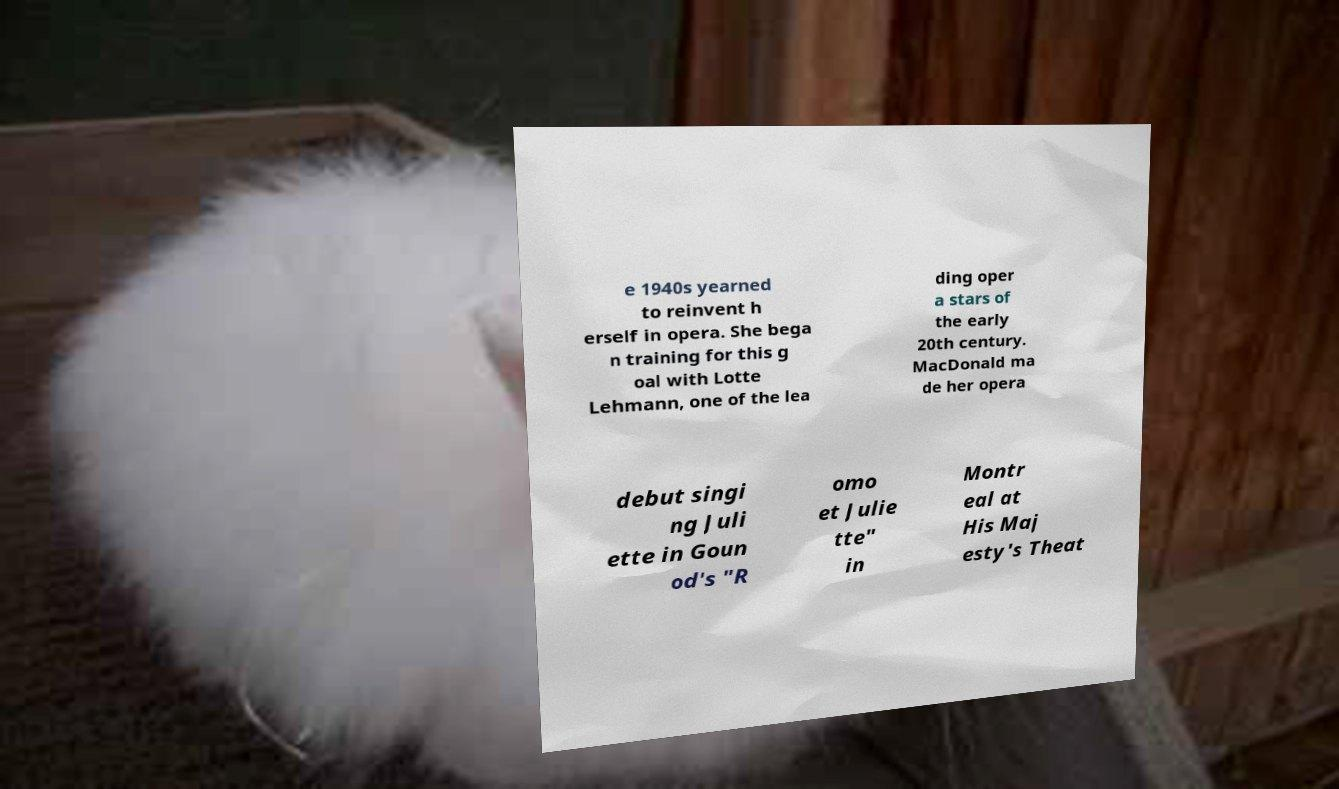I need the written content from this picture converted into text. Can you do that? e 1940s yearned to reinvent h erself in opera. She bega n training for this g oal with Lotte Lehmann, one of the lea ding oper a stars of the early 20th century. MacDonald ma de her opera debut singi ng Juli ette in Goun od's "R omo et Julie tte" in Montr eal at His Maj esty's Theat 